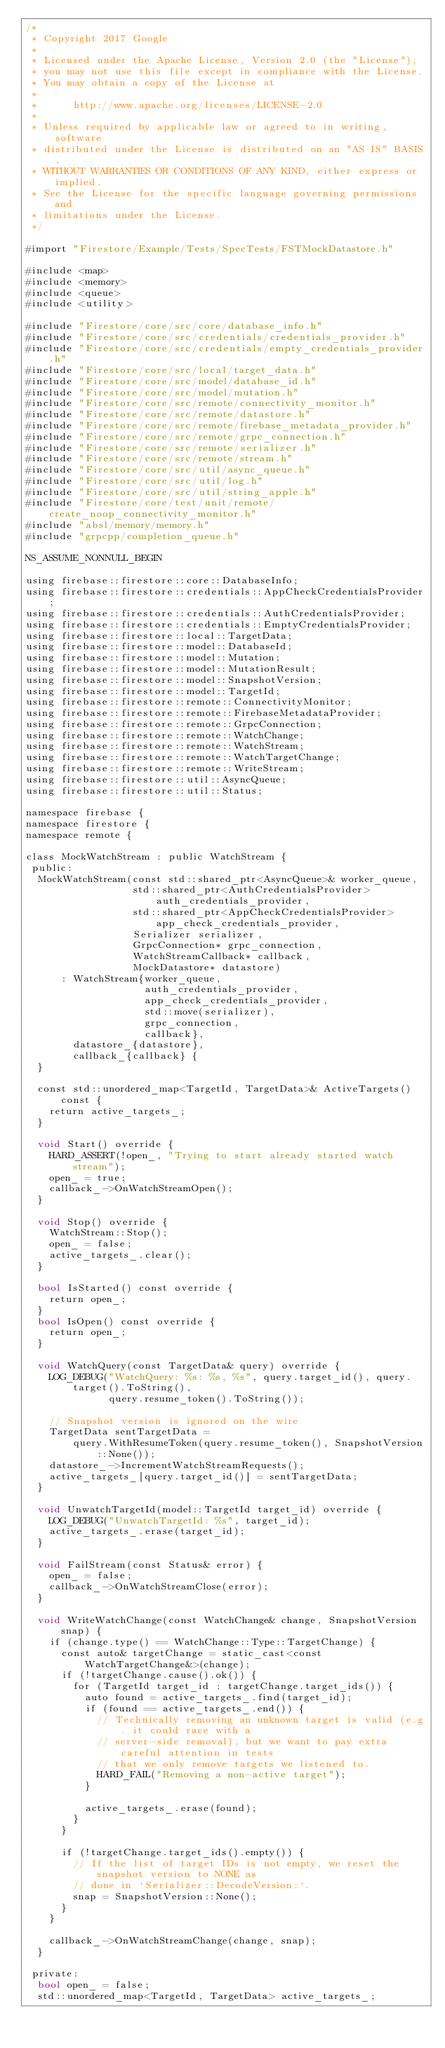<code> <loc_0><loc_0><loc_500><loc_500><_ObjectiveC_>/*
 * Copyright 2017 Google
 *
 * Licensed under the Apache License, Version 2.0 (the "License");
 * you may not use this file except in compliance with the License.
 * You may obtain a copy of the License at
 *
 *      http://www.apache.org/licenses/LICENSE-2.0
 *
 * Unless required by applicable law or agreed to in writing, software
 * distributed under the License is distributed on an "AS IS" BASIS,
 * WITHOUT WARRANTIES OR CONDITIONS OF ANY KIND, either express or implied.
 * See the License for the specific language governing permissions and
 * limitations under the License.
 */

#import "Firestore/Example/Tests/SpecTests/FSTMockDatastore.h"

#include <map>
#include <memory>
#include <queue>
#include <utility>

#include "Firestore/core/src/core/database_info.h"
#include "Firestore/core/src/credentials/credentials_provider.h"
#include "Firestore/core/src/credentials/empty_credentials_provider.h"
#include "Firestore/core/src/local/target_data.h"
#include "Firestore/core/src/model/database_id.h"
#include "Firestore/core/src/model/mutation.h"
#include "Firestore/core/src/remote/connectivity_monitor.h"
#include "Firestore/core/src/remote/datastore.h"
#include "Firestore/core/src/remote/firebase_metadata_provider.h"
#include "Firestore/core/src/remote/grpc_connection.h"
#include "Firestore/core/src/remote/serializer.h"
#include "Firestore/core/src/remote/stream.h"
#include "Firestore/core/src/util/async_queue.h"
#include "Firestore/core/src/util/log.h"
#include "Firestore/core/src/util/string_apple.h"
#include "Firestore/core/test/unit/remote/create_noop_connectivity_monitor.h"
#include "absl/memory/memory.h"
#include "grpcpp/completion_queue.h"

NS_ASSUME_NONNULL_BEGIN

using firebase::firestore::core::DatabaseInfo;
using firebase::firestore::credentials::AppCheckCredentialsProvider;
using firebase::firestore::credentials::AuthCredentialsProvider;
using firebase::firestore::credentials::EmptyCredentialsProvider;
using firebase::firestore::local::TargetData;
using firebase::firestore::model::DatabaseId;
using firebase::firestore::model::Mutation;
using firebase::firestore::model::MutationResult;
using firebase::firestore::model::SnapshotVersion;
using firebase::firestore::model::TargetId;
using firebase::firestore::remote::ConnectivityMonitor;
using firebase::firestore::remote::FirebaseMetadataProvider;
using firebase::firestore::remote::GrpcConnection;
using firebase::firestore::remote::WatchChange;
using firebase::firestore::remote::WatchStream;
using firebase::firestore::remote::WatchTargetChange;
using firebase::firestore::remote::WriteStream;
using firebase::firestore::util::AsyncQueue;
using firebase::firestore::util::Status;

namespace firebase {
namespace firestore {
namespace remote {

class MockWatchStream : public WatchStream {
 public:
  MockWatchStream(const std::shared_ptr<AsyncQueue>& worker_queue,
                  std::shared_ptr<AuthCredentialsProvider> auth_credentials_provider,
                  std::shared_ptr<AppCheckCredentialsProvider> app_check_credentials_provider,
                  Serializer serializer,
                  GrpcConnection* grpc_connection,
                  WatchStreamCallback* callback,
                  MockDatastore* datastore)
      : WatchStream{worker_queue,
                    auth_credentials_provider,
                    app_check_credentials_provider,
                    std::move(serializer),
                    grpc_connection,
                    callback},
        datastore_{datastore},
        callback_{callback} {
  }

  const std::unordered_map<TargetId, TargetData>& ActiveTargets() const {
    return active_targets_;
  }

  void Start() override {
    HARD_ASSERT(!open_, "Trying to start already started watch stream");
    open_ = true;
    callback_->OnWatchStreamOpen();
  }

  void Stop() override {
    WatchStream::Stop();
    open_ = false;
    active_targets_.clear();
  }

  bool IsStarted() const override {
    return open_;
  }
  bool IsOpen() const override {
    return open_;
  }

  void WatchQuery(const TargetData& query) override {
    LOG_DEBUG("WatchQuery: %s: %s, %s", query.target_id(), query.target().ToString(),
              query.resume_token().ToString());

    // Snapshot version is ignored on the wire
    TargetData sentTargetData =
        query.WithResumeToken(query.resume_token(), SnapshotVersion::None());
    datastore_->IncrementWatchStreamRequests();
    active_targets_[query.target_id()] = sentTargetData;
  }

  void UnwatchTargetId(model::TargetId target_id) override {
    LOG_DEBUG("UnwatchTargetId: %s", target_id);
    active_targets_.erase(target_id);
  }

  void FailStream(const Status& error) {
    open_ = false;
    callback_->OnWatchStreamClose(error);
  }

  void WriteWatchChange(const WatchChange& change, SnapshotVersion snap) {
    if (change.type() == WatchChange::Type::TargetChange) {
      const auto& targetChange = static_cast<const WatchTargetChange&>(change);
      if (!targetChange.cause().ok()) {
        for (TargetId target_id : targetChange.target_ids()) {
          auto found = active_targets_.find(target_id);
          if (found == active_targets_.end()) {
            // Technically removing an unknown target is valid (e.g. it could race with a
            // server-side removal), but we want to pay extra careful attention in tests
            // that we only remove targets we listened to.
            HARD_FAIL("Removing a non-active target");
          }

          active_targets_.erase(found);
        }
      }

      if (!targetChange.target_ids().empty()) {
        // If the list of target IDs is not empty, we reset the snapshot version to NONE as
        // done in `Serializer::DecodeVersion:`.
        snap = SnapshotVersion::None();
      }
    }

    callback_->OnWatchStreamChange(change, snap);
  }

 private:
  bool open_ = false;
  std::unordered_map<TargetId, TargetData> active_targets_;</code> 